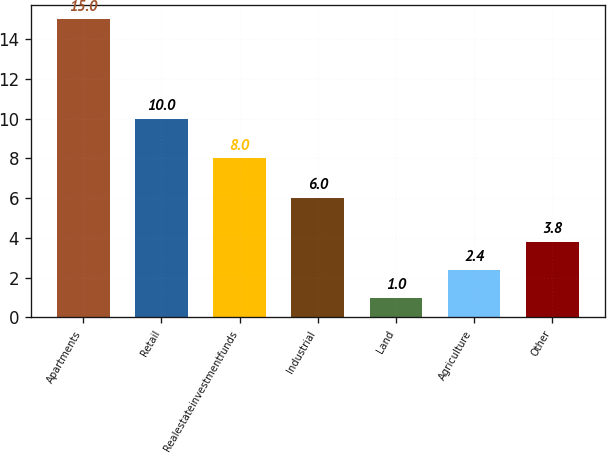<chart> <loc_0><loc_0><loc_500><loc_500><bar_chart><fcel>Apartments<fcel>Retail<fcel>Realestateinvestmentfunds<fcel>Industrial<fcel>Land<fcel>Agriculture<fcel>Other<nl><fcel>15<fcel>10<fcel>8<fcel>6<fcel>1<fcel>2.4<fcel>3.8<nl></chart> 